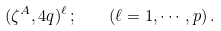<formula> <loc_0><loc_0><loc_500><loc_500>( \zeta ^ { A } , 4 q ) ^ { \ell } \, ; \quad ( \ell = 1 , \cdots , p ) \, .</formula> 